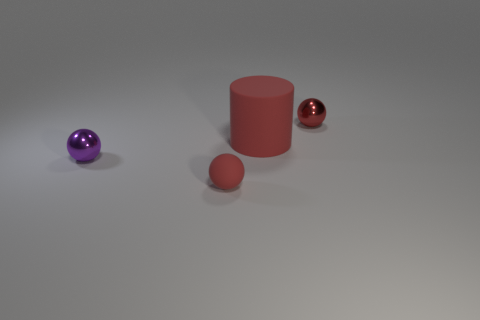Subtract all metal spheres. How many spheres are left? 1 Subtract all balls. How many objects are left? 1 Subtract 1 balls. How many balls are left? 2 Subtract all cylinders. Subtract all purple spheres. How many objects are left? 2 Add 1 rubber balls. How many rubber balls are left? 2 Add 2 small yellow matte balls. How many small yellow matte balls exist? 2 Add 4 red cylinders. How many objects exist? 8 Subtract all purple spheres. How many spheres are left? 2 Subtract 2 red spheres. How many objects are left? 2 Subtract all red spheres. Subtract all gray cubes. How many spheres are left? 1 